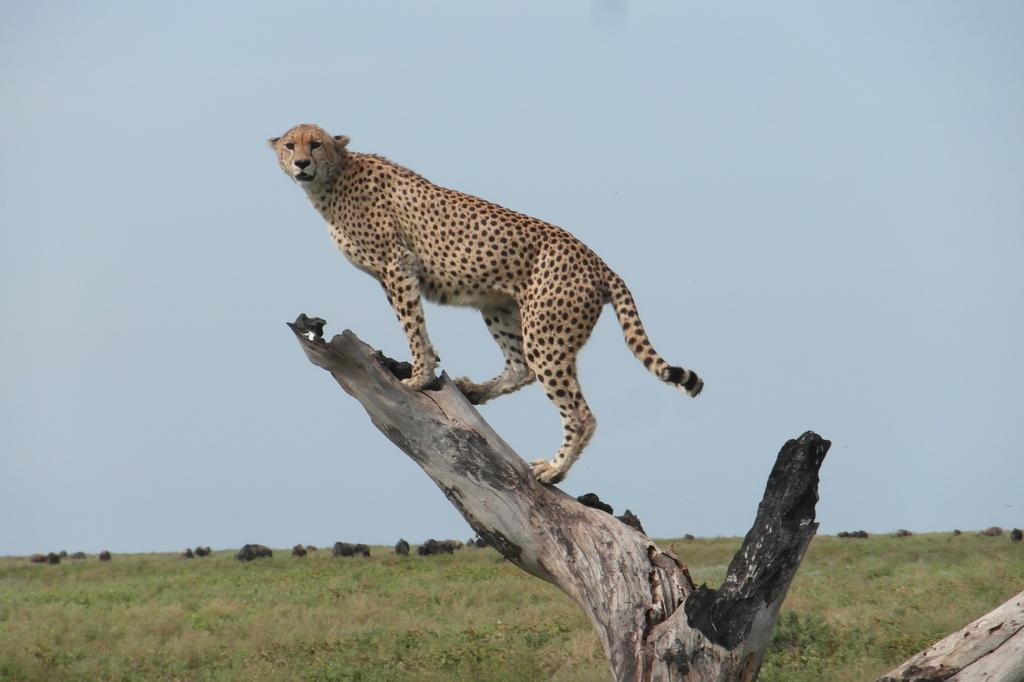What animal is the main subject of the image? There is a cheetah in the image. Where is the cheetah located in the image? The cheetah is on a tree trunk. What can be seen in the background of the image? There are trees in the background of the image. What is visible at the bottom of the image? The ground is visible at the bottom of the image. What is visible at the top of the image? The sky is visible at the top of the image. What type of watch is the cheetah wearing in the image? There is no watch present in the image. The cheetah is an animal and does not wear watches. 